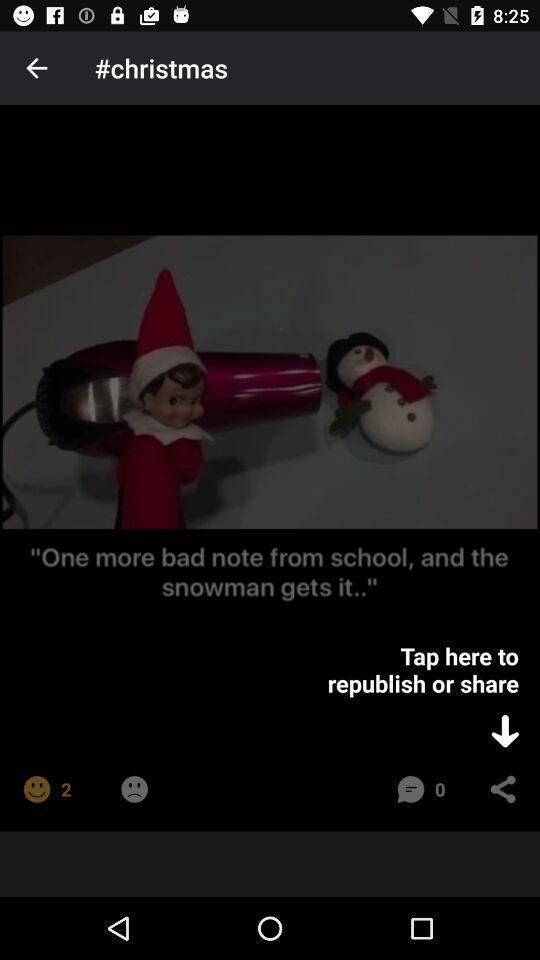Describe the key features of this screenshot. Pop up guiding to share a meme in social app. 